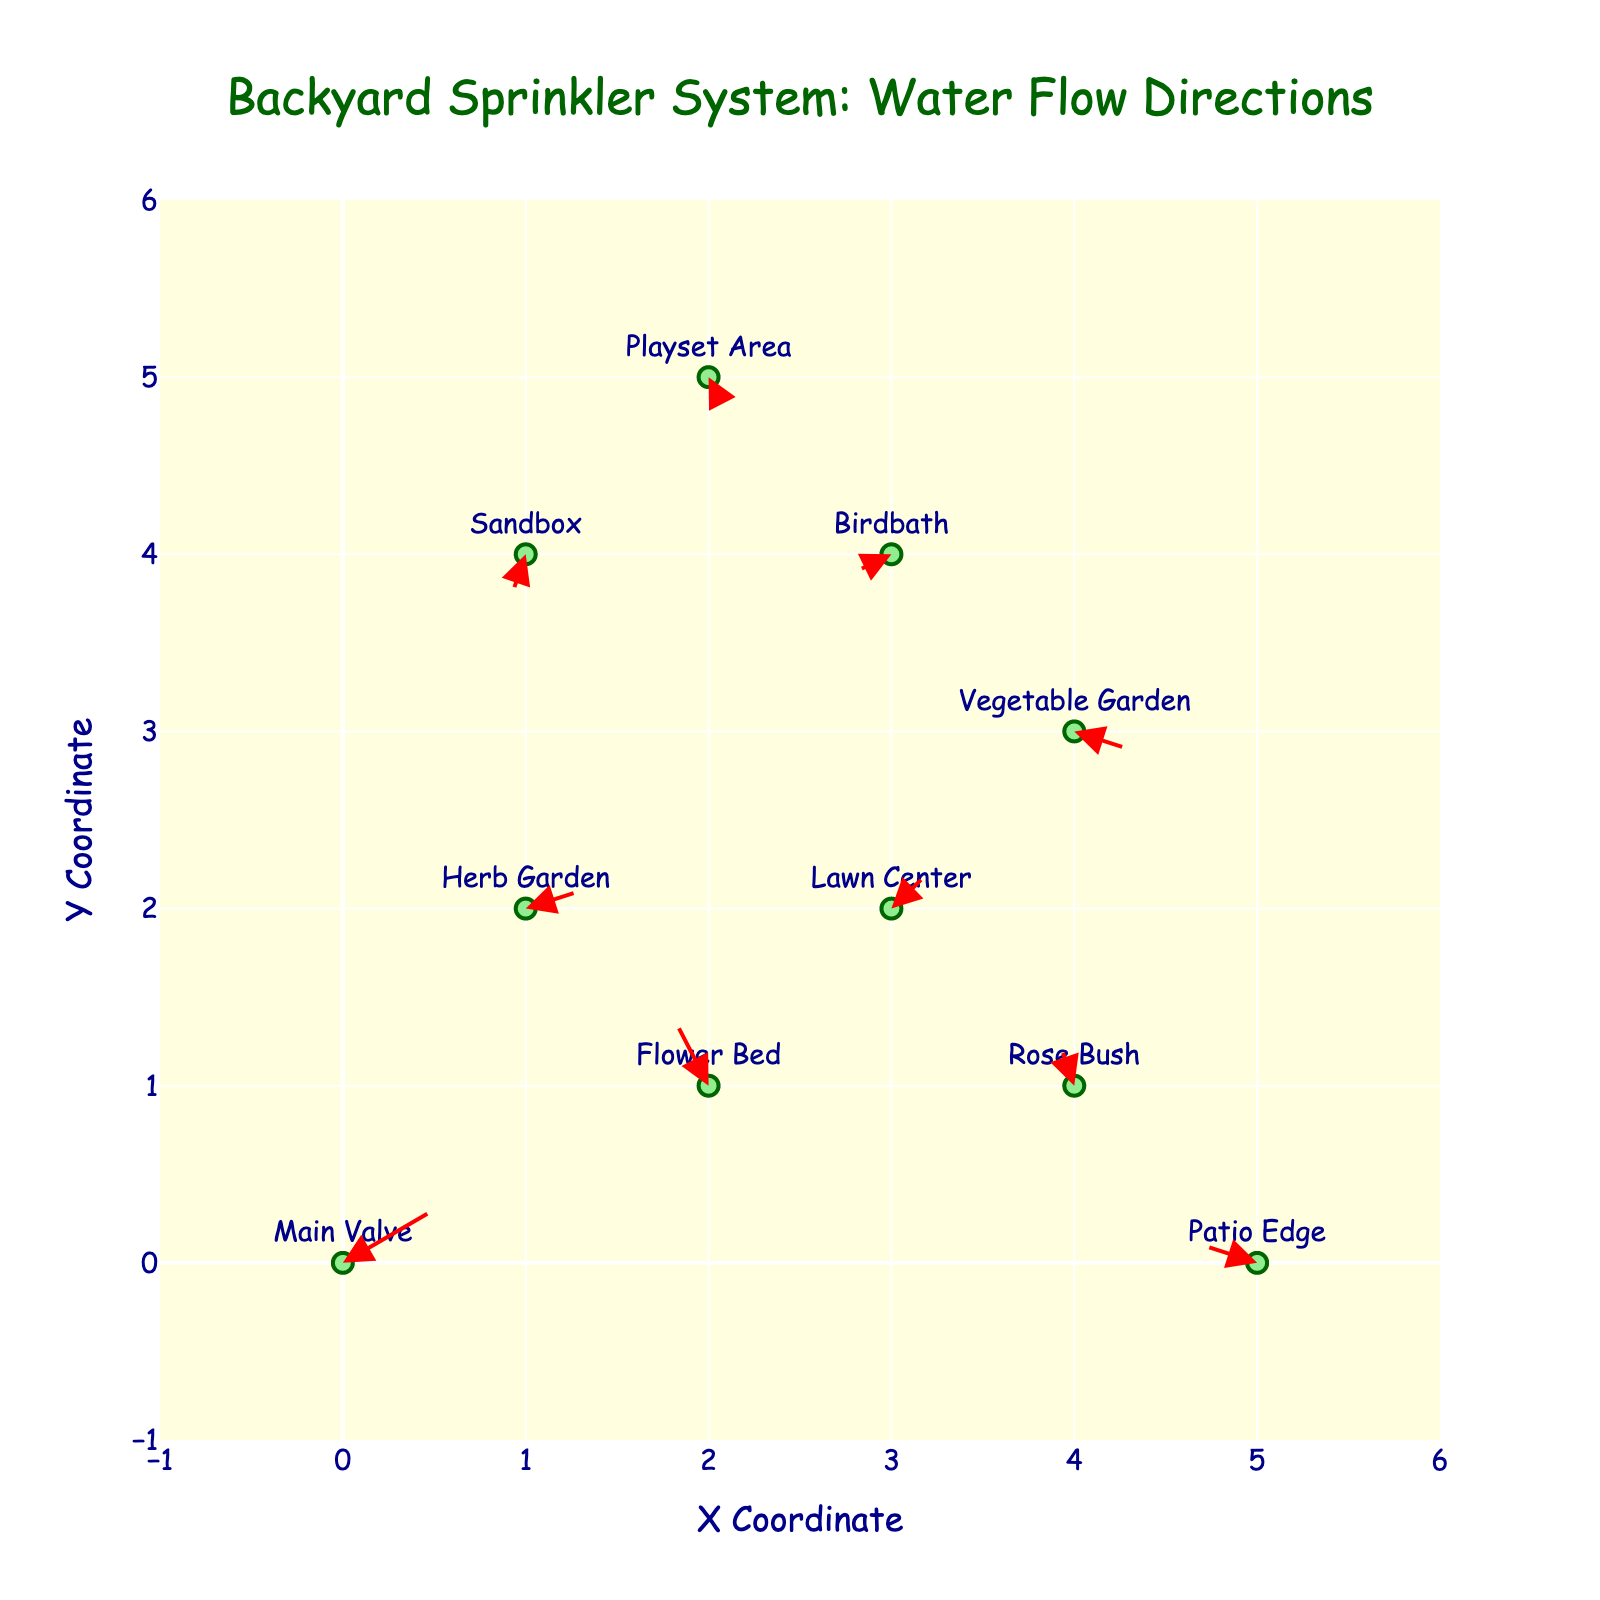how many locations are displayed on the plot? The plot shows markers for each location. Counting these markers will give the number of locations.
Answer: 10 what is the x-axis range in the plot? The x-axis range can be determined by looking at the minimum and maximum values labeled on the x-axis.
Answer: -1 to 6 which location has the longest arrow indicating the strongest water flow velocity? By visually comparing the lengths of the arrows, the location with the longest arrow represents the strongest water flow velocity.
Answer: Main Valve which locations have arrows pointing downwards? Arrows pointing downwards have a negative y-component (v). Look for these in the plot for each location.
Answer: Sandbox, Birdbath, Vegetable Garden, Playset Area what is the coordinate of the Lawn Center location? The coordinates for the Lawn Center can be obtained by looking at the position of the marker labeled 'Lawn Center'.
Answer: (3, 2) which location has the water flow direction exactly opposite to the Herb Garden? The Herb Garden has an arrow pointing in a specific direction. An exactly opposite direction would have reversed u and v components (change signs).
Answer: Patio Edge what is the average x-coordinate of all the locations? Calculate the average x-coordinate by summing all the x-coordinates and dividing by the number of locations.
Answer: 2.5 which location has the smallest water flow velocity? The smallest water flow velocity can be determined by finding the arrow with the shortest length.
Answer: Sandbox which locations have a positive x-component for water flow? Locations with positive x-components have u values greater than 0. Look for these in the plot for each location.
Answer: Main Valve, Vegetable Garden, Lawn Center, Herb Garden is the direction of water flow at the Playset Area more vertical or horizontal? Compare the magnitude of the x-component (u) and the y-component (v) to determine if the flow is more vertical or horizontal.
Answer: More vertical 